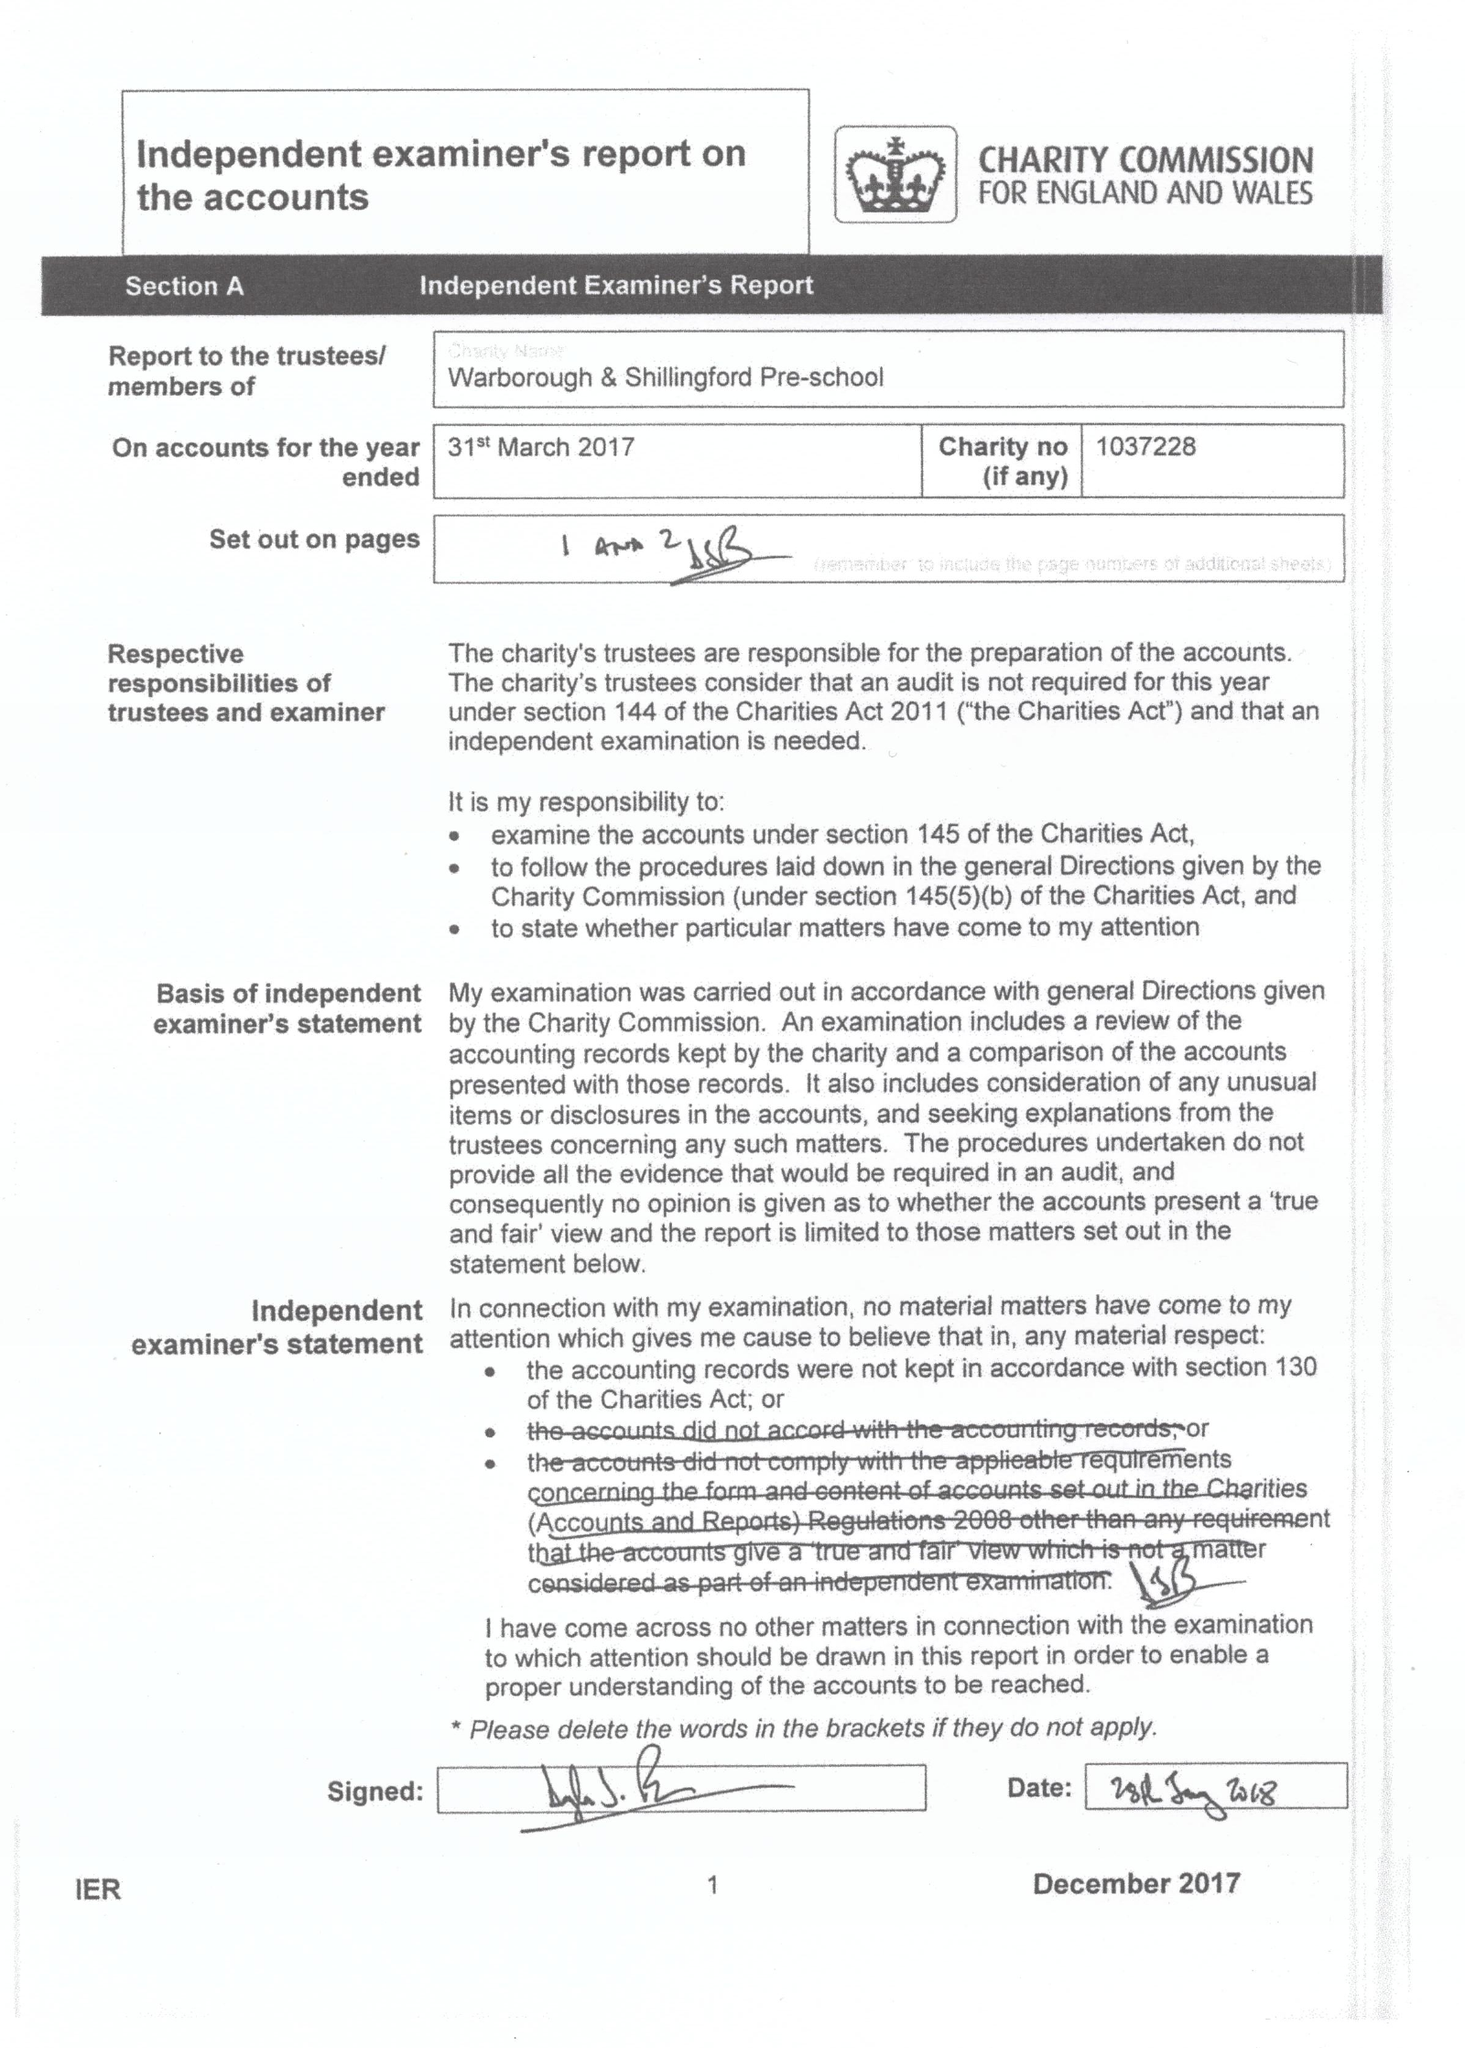What is the value for the address__street_line?
Answer the question using a single word or phrase. 16 THAME ROAD 